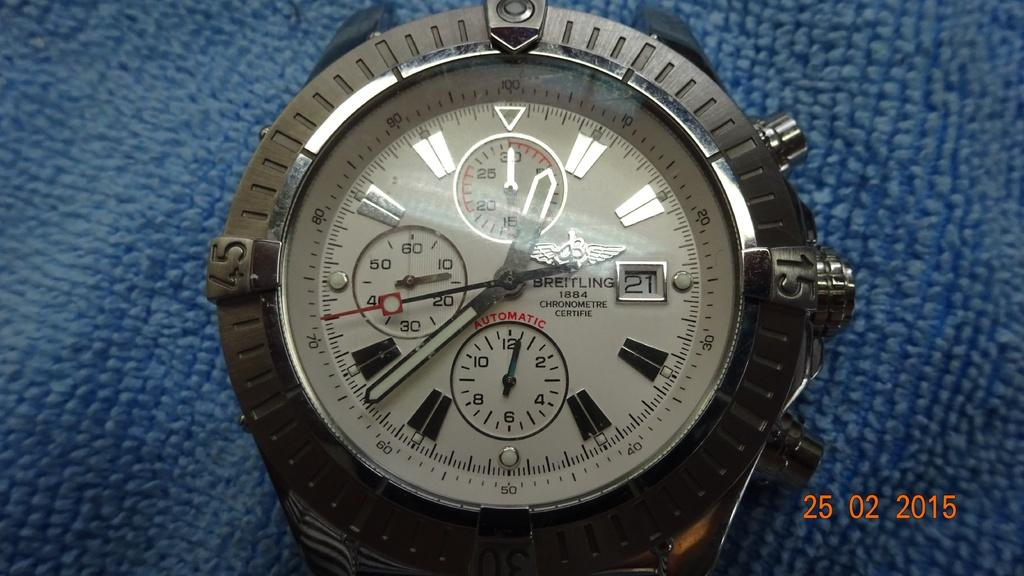<image>
Describe the image concisely. A Breitling chronometre watch on a blue background. 